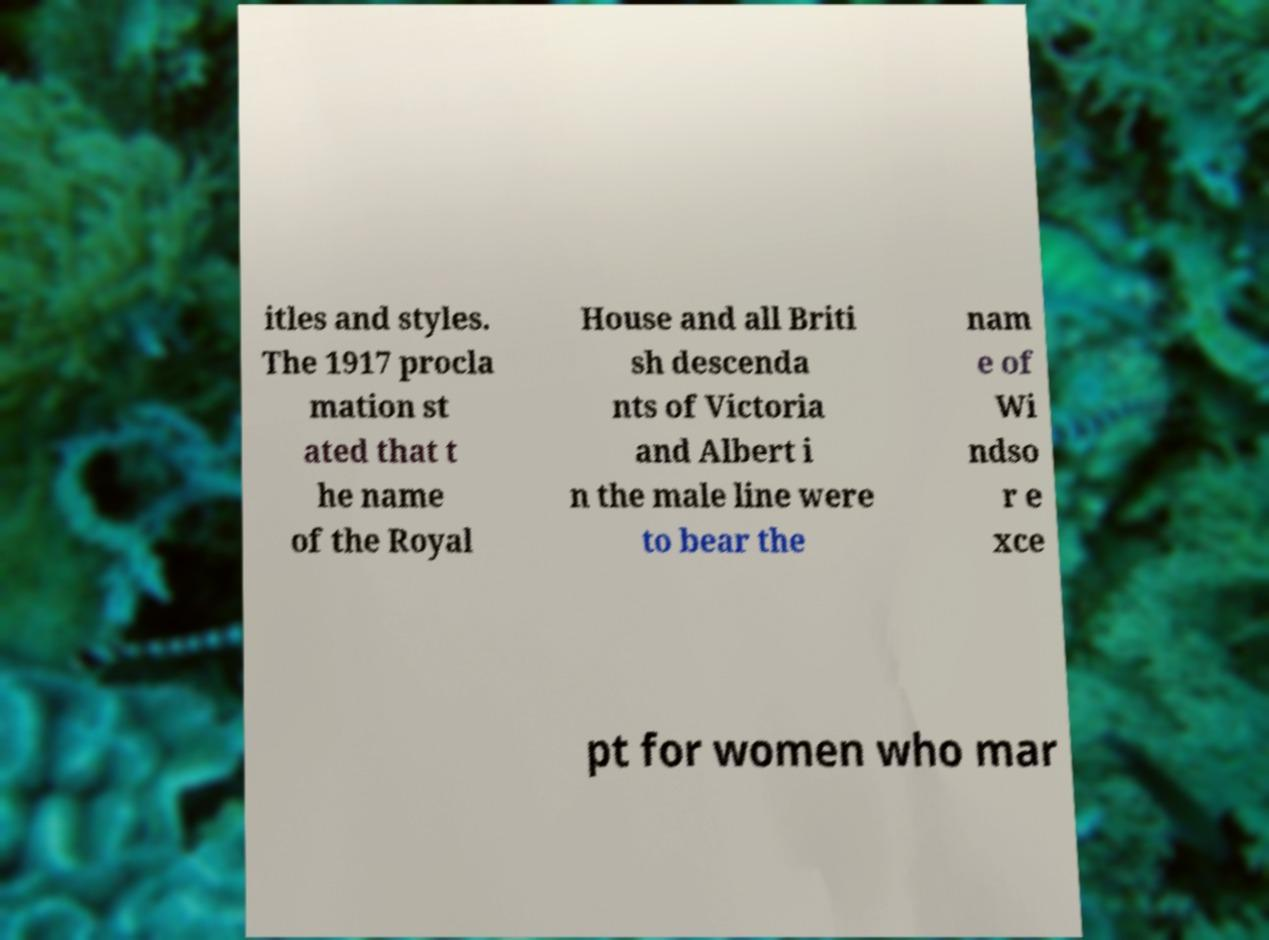Can you read and provide the text displayed in the image?This photo seems to have some interesting text. Can you extract and type it out for me? itles and styles. The 1917 procla mation st ated that t he name of the Royal House and all Briti sh descenda nts of Victoria and Albert i n the male line were to bear the nam e of Wi ndso r e xce pt for women who mar 